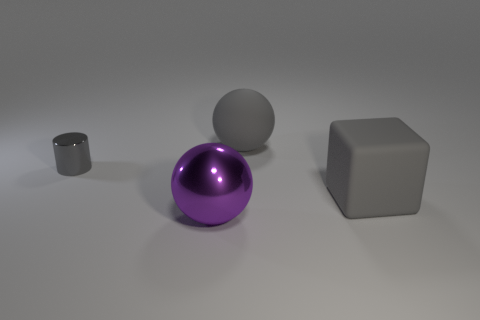Add 2 large rubber cubes. How many objects exist? 6 Subtract all blocks. How many objects are left? 3 Add 3 small red objects. How many small red objects exist? 3 Subtract 0 red balls. How many objects are left? 4 Subtract all small gray shiny cylinders. Subtract all metal balls. How many objects are left? 2 Add 4 large spheres. How many large spheres are left? 6 